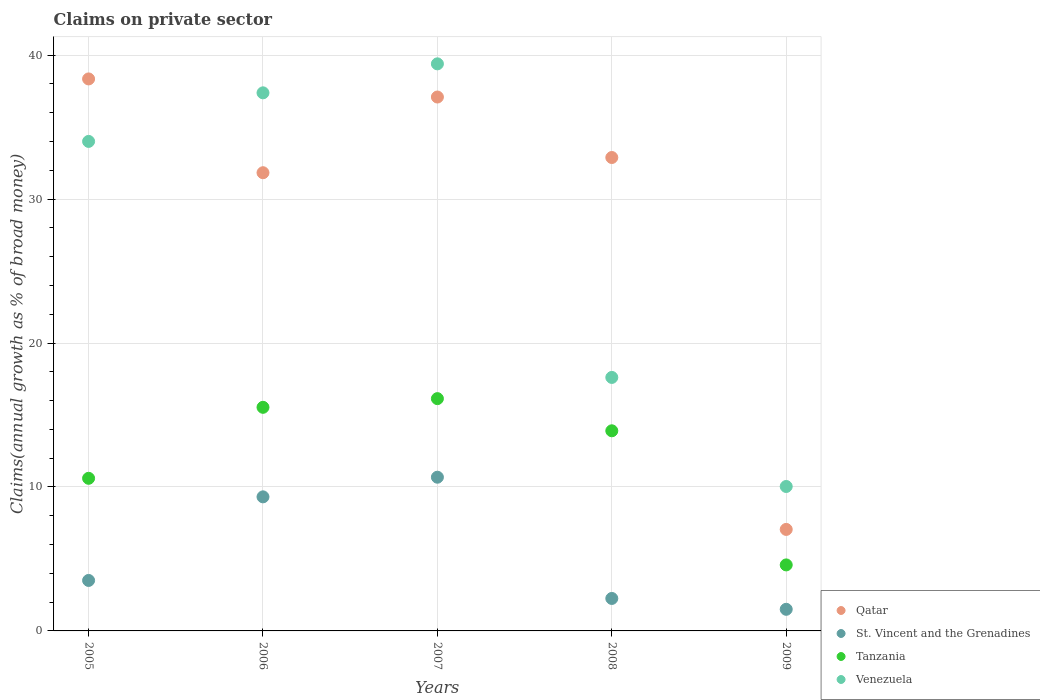What is the percentage of broad money claimed on private sector in Venezuela in 2007?
Your answer should be compact. 39.39. Across all years, what is the maximum percentage of broad money claimed on private sector in Venezuela?
Your response must be concise. 39.39. Across all years, what is the minimum percentage of broad money claimed on private sector in St. Vincent and the Grenadines?
Provide a short and direct response. 1.5. In which year was the percentage of broad money claimed on private sector in St. Vincent and the Grenadines maximum?
Give a very brief answer. 2007. What is the total percentage of broad money claimed on private sector in Venezuela in the graph?
Provide a short and direct response. 138.42. What is the difference between the percentage of broad money claimed on private sector in St. Vincent and the Grenadines in 2006 and that in 2008?
Make the answer very short. 7.06. What is the difference between the percentage of broad money claimed on private sector in Qatar in 2007 and the percentage of broad money claimed on private sector in Venezuela in 2008?
Provide a short and direct response. 19.48. What is the average percentage of broad money claimed on private sector in Tanzania per year?
Your response must be concise. 12.15. In the year 2005, what is the difference between the percentage of broad money claimed on private sector in St. Vincent and the Grenadines and percentage of broad money claimed on private sector in Venezuela?
Make the answer very short. -30.5. In how many years, is the percentage of broad money claimed on private sector in St. Vincent and the Grenadines greater than 30 %?
Provide a succinct answer. 0. What is the ratio of the percentage of broad money claimed on private sector in St. Vincent and the Grenadines in 2007 to that in 2009?
Ensure brevity in your answer.  7.11. Is the percentage of broad money claimed on private sector in Qatar in 2005 less than that in 2009?
Provide a succinct answer. No. What is the difference between the highest and the second highest percentage of broad money claimed on private sector in Venezuela?
Keep it short and to the point. 2.01. What is the difference between the highest and the lowest percentage of broad money claimed on private sector in St. Vincent and the Grenadines?
Offer a terse response. 9.18. Is the sum of the percentage of broad money claimed on private sector in Qatar in 2006 and 2007 greater than the maximum percentage of broad money claimed on private sector in Venezuela across all years?
Provide a short and direct response. Yes. Is it the case that in every year, the sum of the percentage of broad money claimed on private sector in Tanzania and percentage of broad money claimed on private sector in St. Vincent and the Grenadines  is greater than the sum of percentage of broad money claimed on private sector in Venezuela and percentage of broad money claimed on private sector in Qatar?
Provide a succinct answer. No. Is it the case that in every year, the sum of the percentage of broad money claimed on private sector in Tanzania and percentage of broad money claimed on private sector in Qatar  is greater than the percentage of broad money claimed on private sector in St. Vincent and the Grenadines?
Ensure brevity in your answer.  Yes. Does the percentage of broad money claimed on private sector in Tanzania monotonically increase over the years?
Provide a succinct answer. No. How many dotlines are there?
Make the answer very short. 4. How many years are there in the graph?
Offer a very short reply. 5. What is the difference between two consecutive major ticks on the Y-axis?
Your response must be concise. 10. Are the values on the major ticks of Y-axis written in scientific E-notation?
Ensure brevity in your answer.  No. How many legend labels are there?
Offer a terse response. 4. What is the title of the graph?
Provide a short and direct response. Claims on private sector. What is the label or title of the Y-axis?
Provide a short and direct response. Claims(annual growth as % of broad money). What is the Claims(annual growth as % of broad money) of Qatar in 2005?
Give a very brief answer. 38.35. What is the Claims(annual growth as % of broad money) in St. Vincent and the Grenadines in 2005?
Your response must be concise. 3.51. What is the Claims(annual growth as % of broad money) of Tanzania in 2005?
Your answer should be compact. 10.6. What is the Claims(annual growth as % of broad money) of Venezuela in 2005?
Provide a short and direct response. 34.01. What is the Claims(annual growth as % of broad money) of Qatar in 2006?
Your response must be concise. 31.83. What is the Claims(annual growth as % of broad money) in St. Vincent and the Grenadines in 2006?
Give a very brief answer. 9.31. What is the Claims(annual growth as % of broad money) in Tanzania in 2006?
Give a very brief answer. 15.53. What is the Claims(annual growth as % of broad money) in Venezuela in 2006?
Your answer should be very brief. 37.38. What is the Claims(annual growth as % of broad money) of Qatar in 2007?
Ensure brevity in your answer.  37.09. What is the Claims(annual growth as % of broad money) of St. Vincent and the Grenadines in 2007?
Your response must be concise. 10.68. What is the Claims(annual growth as % of broad money) of Tanzania in 2007?
Your response must be concise. 16.14. What is the Claims(annual growth as % of broad money) of Venezuela in 2007?
Provide a short and direct response. 39.39. What is the Claims(annual growth as % of broad money) of Qatar in 2008?
Ensure brevity in your answer.  32.89. What is the Claims(annual growth as % of broad money) of St. Vincent and the Grenadines in 2008?
Offer a very short reply. 2.26. What is the Claims(annual growth as % of broad money) in Tanzania in 2008?
Your answer should be very brief. 13.9. What is the Claims(annual growth as % of broad money) of Venezuela in 2008?
Keep it short and to the point. 17.61. What is the Claims(annual growth as % of broad money) of Qatar in 2009?
Make the answer very short. 7.05. What is the Claims(annual growth as % of broad money) in St. Vincent and the Grenadines in 2009?
Provide a short and direct response. 1.5. What is the Claims(annual growth as % of broad money) in Tanzania in 2009?
Provide a succinct answer. 4.59. What is the Claims(annual growth as % of broad money) in Venezuela in 2009?
Your answer should be very brief. 10.03. Across all years, what is the maximum Claims(annual growth as % of broad money) in Qatar?
Make the answer very short. 38.35. Across all years, what is the maximum Claims(annual growth as % of broad money) of St. Vincent and the Grenadines?
Make the answer very short. 10.68. Across all years, what is the maximum Claims(annual growth as % of broad money) in Tanzania?
Offer a terse response. 16.14. Across all years, what is the maximum Claims(annual growth as % of broad money) of Venezuela?
Keep it short and to the point. 39.39. Across all years, what is the minimum Claims(annual growth as % of broad money) in Qatar?
Ensure brevity in your answer.  7.05. Across all years, what is the minimum Claims(annual growth as % of broad money) in St. Vincent and the Grenadines?
Your answer should be very brief. 1.5. Across all years, what is the minimum Claims(annual growth as % of broad money) in Tanzania?
Your response must be concise. 4.59. Across all years, what is the minimum Claims(annual growth as % of broad money) of Venezuela?
Provide a succinct answer. 10.03. What is the total Claims(annual growth as % of broad money) in Qatar in the graph?
Your answer should be compact. 147.2. What is the total Claims(annual growth as % of broad money) of St. Vincent and the Grenadines in the graph?
Provide a short and direct response. 27.26. What is the total Claims(annual growth as % of broad money) in Tanzania in the graph?
Offer a terse response. 60.76. What is the total Claims(annual growth as % of broad money) in Venezuela in the graph?
Provide a short and direct response. 138.42. What is the difference between the Claims(annual growth as % of broad money) of Qatar in 2005 and that in 2006?
Provide a succinct answer. 6.52. What is the difference between the Claims(annual growth as % of broad money) of St. Vincent and the Grenadines in 2005 and that in 2006?
Provide a succinct answer. -5.81. What is the difference between the Claims(annual growth as % of broad money) in Tanzania in 2005 and that in 2006?
Offer a very short reply. -4.93. What is the difference between the Claims(annual growth as % of broad money) in Venezuela in 2005 and that in 2006?
Offer a terse response. -3.37. What is the difference between the Claims(annual growth as % of broad money) of Qatar in 2005 and that in 2007?
Offer a terse response. 1.26. What is the difference between the Claims(annual growth as % of broad money) of St. Vincent and the Grenadines in 2005 and that in 2007?
Keep it short and to the point. -7.17. What is the difference between the Claims(annual growth as % of broad money) of Tanzania in 2005 and that in 2007?
Offer a very short reply. -5.53. What is the difference between the Claims(annual growth as % of broad money) in Venezuela in 2005 and that in 2007?
Give a very brief answer. -5.39. What is the difference between the Claims(annual growth as % of broad money) in Qatar in 2005 and that in 2008?
Give a very brief answer. 5.46. What is the difference between the Claims(annual growth as % of broad money) of St. Vincent and the Grenadines in 2005 and that in 2008?
Keep it short and to the point. 1.25. What is the difference between the Claims(annual growth as % of broad money) in Tanzania in 2005 and that in 2008?
Your answer should be compact. -3.3. What is the difference between the Claims(annual growth as % of broad money) of Venezuela in 2005 and that in 2008?
Provide a short and direct response. 16.4. What is the difference between the Claims(annual growth as % of broad money) of Qatar in 2005 and that in 2009?
Make the answer very short. 31.29. What is the difference between the Claims(annual growth as % of broad money) of St. Vincent and the Grenadines in 2005 and that in 2009?
Provide a succinct answer. 2. What is the difference between the Claims(annual growth as % of broad money) of Tanzania in 2005 and that in 2009?
Offer a very short reply. 6.02. What is the difference between the Claims(annual growth as % of broad money) of Venezuela in 2005 and that in 2009?
Your answer should be compact. 23.97. What is the difference between the Claims(annual growth as % of broad money) in Qatar in 2006 and that in 2007?
Your answer should be compact. -5.26. What is the difference between the Claims(annual growth as % of broad money) in St. Vincent and the Grenadines in 2006 and that in 2007?
Ensure brevity in your answer.  -1.36. What is the difference between the Claims(annual growth as % of broad money) in Tanzania in 2006 and that in 2007?
Offer a very short reply. -0.6. What is the difference between the Claims(annual growth as % of broad money) of Venezuela in 2006 and that in 2007?
Provide a succinct answer. -2.01. What is the difference between the Claims(annual growth as % of broad money) of Qatar in 2006 and that in 2008?
Your response must be concise. -1.06. What is the difference between the Claims(annual growth as % of broad money) in St. Vincent and the Grenadines in 2006 and that in 2008?
Ensure brevity in your answer.  7.06. What is the difference between the Claims(annual growth as % of broad money) in Tanzania in 2006 and that in 2008?
Provide a short and direct response. 1.63. What is the difference between the Claims(annual growth as % of broad money) of Venezuela in 2006 and that in 2008?
Keep it short and to the point. 19.77. What is the difference between the Claims(annual growth as % of broad money) of Qatar in 2006 and that in 2009?
Provide a succinct answer. 24.78. What is the difference between the Claims(annual growth as % of broad money) in St. Vincent and the Grenadines in 2006 and that in 2009?
Provide a short and direct response. 7.81. What is the difference between the Claims(annual growth as % of broad money) in Tanzania in 2006 and that in 2009?
Provide a succinct answer. 10.95. What is the difference between the Claims(annual growth as % of broad money) in Venezuela in 2006 and that in 2009?
Offer a very short reply. 27.35. What is the difference between the Claims(annual growth as % of broad money) in Qatar in 2007 and that in 2008?
Offer a terse response. 4.2. What is the difference between the Claims(annual growth as % of broad money) in St. Vincent and the Grenadines in 2007 and that in 2008?
Keep it short and to the point. 8.42. What is the difference between the Claims(annual growth as % of broad money) in Tanzania in 2007 and that in 2008?
Your answer should be compact. 2.23. What is the difference between the Claims(annual growth as % of broad money) of Venezuela in 2007 and that in 2008?
Give a very brief answer. 21.78. What is the difference between the Claims(annual growth as % of broad money) in Qatar in 2007 and that in 2009?
Provide a short and direct response. 30.04. What is the difference between the Claims(annual growth as % of broad money) of St. Vincent and the Grenadines in 2007 and that in 2009?
Your answer should be very brief. 9.18. What is the difference between the Claims(annual growth as % of broad money) in Tanzania in 2007 and that in 2009?
Keep it short and to the point. 11.55. What is the difference between the Claims(annual growth as % of broad money) of Venezuela in 2007 and that in 2009?
Your answer should be compact. 29.36. What is the difference between the Claims(annual growth as % of broad money) of Qatar in 2008 and that in 2009?
Provide a short and direct response. 25.84. What is the difference between the Claims(annual growth as % of broad money) of St. Vincent and the Grenadines in 2008 and that in 2009?
Keep it short and to the point. 0.75. What is the difference between the Claims(annual growth as % of broad money) in Tanzania in 2008 and that in 2009?
Your response must be concise. 9.32. What is the difference between the Claims(annual growth as % of broad money) of Venezuela in 2008 and that in 2009?
Provide a short and direct response. 7.58. What is the difference between the Claims(annual growth as % of broad money) in Qatar in 2005 and the Claims(annual growth as % of broad money) in St. Vincent and the Grenadines in 2006?
Offer a very short reply. 29.03. What is the difference between the Claims(annual growth as % of broad money) in Qatar in 2005 and the Claims(annual growth as % of broad money) in Tanzania in 2006?
Offer a very short reply. 22.81. What is the difference between the Claims(annual growth as % of broad money) of Qatar in 2005 and the Claims(annual growth as % of broad money) of Venezuela in 2006?
Your response must be concise. 0.97. What is the difference between the Claims(annual growth as % of broad money) of St. Vincent and the Grenadines in 2005 and the Claims(annual growth as % of broad money) of Tanzania in 2006?
Provide a short and direct response. -12.03. What is the difference between the Claims(annual growth as % of broad money) in St. Vincent and the Grenadines in 2005 and the Claims(annual growth as % of broad money) in Venezuela in 2006?
Keep it short and to the point. -33.87. What is the difference between the Claims(annual growth as % of broad money) of Tanzania in 2005 and the Claims(annual growth as % of broad money) of Venezuela in 2006?
Keep it short and to the point. -26.78. What is the difference between the Claims(annual growth as % of broad money) of Qatar in 2005 and the Claims(annual growth as % of broad money) of St. Vincent and the Grenadines in 2007?
Keep it short and to the point. 27.67. What is the difference between the Claims(annual growth as % of broad money) in Qatar in 2005 and the Claims(annual growth as % of broad money) in Tanzania in 2007?
Your response must be concise. 22.21. What is the difference between the Claims(annual growth as % of broad money) of Qatar in 2005 and the Claims(annual growth as % of broad money) of Venezuela in 2007?
Make the answer very short. -1.05. What is the difference between the Claims(annual growth as % of broad money) in St. Vincent and the Grenadines in 2005 and the Claims(annual growth as % of broad money) in Tanzania in 2007?
Offer a terse response. -12.63. What is the difference between the Claims(annual growth as % of broad money) of St. Vincent and the Grenadines in 2005 and the Claims(annual growth as % of broad money) of Venezuela in 2007?
Give a very brief answer. -35.89. What is the difference between the Claims(annual growth as % of broad money) in Tanzania in 2005 and the Claims(annual growth as % of broad money) in Venezuela in 2007?
Make the answer very short. -28.79. What is the difference between the Claims(annual growth as % of broad money) in Qatar in 2005 and the Claims(annual growth as % of broad money) in St. Vincent and the Grenadines in 2008?
Your answer should be very brief. 36.09. What is the difference between the Claims(annual growth as % of broad money) of Qatar in 2005 and the Claims(annual growth as % of broad money) of Tanzania in 2008?
Ensure brevity in your answer.  24.44. What is the difference between the Claims(annual growth as % of broad money) in Qatar in 2005 and the Claims(annual growth as % of broad money) in Venezuela in 2008?
Provide a succinct answer. 20.74. What is the difference between the Claims(annual growth as % of broad money) in St. Vincent and the Grenadines in 2005 and the Claims(annual growth as % of broad money) in Tanzania in 2008?
Provide a short and direct response. -10.4. What is the difference between the Claims(annual growth as % of broad money) of St. Vincent and the Grenadines in 2005 and the Claims(annual growth as % of broad money) of Venezuela in 2008?
Keep it short and to the point. -14.1. What is the difference between the Claims(annual growth as % of broad money) in Tanzania in 2005 and the Claims(annual growth as % of broad money) in Venezuela in 2008?
Your answer should be compact. -7.01. What is the difference between the Claims(annual growth as % of broad money) in Qatar in 2005 and the Claims(annual growth as % of broad money) in St. Vincent and the Grenadines in 2009?
Your answer should be very brief. 36.84. What is the difference between the Claims(annual growth as % of broad money) in Qatar in 2005 and the Claims(annual growth as % of broad money) in Tanzania in 2009?
Keep it short and to the point. 33.76. What is the difference between the Claims(annual growth as % of broad money) in Qatar in 2005 and the Claims(annual growth as % of broad money) in Venezuela in 2009?
Make the answer very short. 28.31. What is the difference between the Claims(annual growth as % of broad money) in St. Vincent and the Grenadines in 2005 and the Claims(annual growth as % of broad money) in Tanzania in 2009?
Give a very brief answer. -1.08. What is the difference between the Claims(annual growth as % of broad money) in St. Vincent and the Grenadines in 2005 and the Claims(annual growth as % of broad money) in Venezuela in 2009?
Offer a terse response. -6.53. What is the difference between the Claims(annual growth as % of broad money) in Tanzania in 2005 and the Claims(annual growth as % of broad money) in Venezuela in 2009?
Provide a short and direct response. 0.57. What is the difference between the Claims(annual growth as % of broad money) in Qatar in 2006 and the Claims(annual growth as % of broad money) in St. Vincent and the Grenadines in 2007?
Your response must be concise. 21.15. What is the difference between the Claims(annual growth as % of broad money) in Qatar in 2006 and the Claims(annual growth as % of broad money) in Tanzania in 2007?
Your answer should be very brief. 15.69. What is the difference between the Claims(annual growth as % of broad money) in Qatar in 2006 and the Claims(annual growth as % of broad money) in Venezuela in 2007?
Your response must be concise. -7.56. What is the difference between the Claims(annual growth as % of broad money) of St. Vincent and the Grenadines in 2006 and the Claims(annual growth as % of broad money) of Tanzania in 2007?
Provide a short and direct response. -6.82. What is the difference between the Claims(annual growth as % of broad money) in St. Vincent and the Grenadines in 2006 and the Claims(annual growth as % of broad money) in Venezuela in 2007?
Make the answer very short. -30.08. What is the difference between the Claims(annual growth as % of broad money) of Tanzania in 2006 and the Claims(annual growth as % of broad money) of Venezuela in 2007?
Your answer should be compact. -23.86. What is the difference between the Claims(annual growth as % of broad money) in Qatar in 2006 and the Claims(annual growth as % of broad money) in St. Vincent and the Grenadines in 2008?
Your response must be concise. 29.58. What is the difference between the Claims(annual growth as % of broad money) of Qatar in 2006 and the Claims(annual growth as % of broad money) of Tanzania in 2008?
Provide a succinct answer. 17.93. What is the difference between the Claims(annual growth as % of broad money) in Qatar in 2006 and the Claims(annual growth as % of broad money) in Venezuela in 2008?
Provide a succinct answer. 14.22. What is the difference between the Claims(annual growth as % of broad money) in St. Vincent and the Grenadines in 2006 and the Claims(annual growth as % of broad money) in Tanzania in 2008?
Offer a terse response. -4.59. What is the difference between the Claims(annual growth as % of broad money) of St. Vincent and the Grenadines in 2006 and the Claims(annual growth as % of broad money) of Venezuela in 2008?
Your response must be concise. -8.3. What is the difference between the Claims(annual growth as % of broad money) of Tanzania in 2006 and the Claims(annual growth as % of broad money) of Venezuela in 2008?
Ensure brevity in your answer.  -2.08. What is the difference between the Claims(annual growth as % of broad money) in Qatar in 2006 and the Claims(annual growth as % of broad money) in St. Vincent and the Grenadines in 2009?
Keep it short and to the point. 30.33. What is the difference between the Claims(annual growth as % of broad money) in Qatar in 2006 and the Claims(annual growth as % of broad money) in Tanzania in 2009?
Give a very brief answer. 27.24. What is the difference between the Claims(annual growth as % of broad money) in Qatar in 2006 and the Claims(annual growth as % of broad money) in Venezuela in 2009?
Offer a very short reply. 21.8. What is the difference between the Claims(annual growth as % of broad money) in St. Vincent and the Grenadines in 2006 and the Claims(annual growth as % of broad money) in Tanzania in 2009?
Your answer should be compact. 4.73. What is the difference between the Claims(annual growth as % of broad money) in St. Vincent and the Grenadines in 2006 and the Claims(annual growth as % of broad money) in Venezuela in 2009?
Your answer should be very brief. -0.72. What is the difference between the Claims(annual growth as % of broad money) of Tanzania in 2006 and the Claims(annual growth as % of broad money) of Venezuela in 2009?
Your answer should be very brief. 5.5. What is the difference between the Claims(annual growth as % of broad money) in Qatar in 2007 and the Claims(annual growth as % of broad money) in St. Vincent and the Grenadines in 2008?
Make the answer very short. 34.83. What is the difference between the Claims(annual growth as % of broad money) in Qatar in 2007 and the Claims(annual growth as % of broad money) in Tanzania in 2008?
Provide a succinct answer. 23.19. What is the difference between the Claims(annual growth as % of broad money) in Qatar in 2007 and the Claims(annual growth as % of broad money) in Venezuela in 2008?
Make the answer very short. 19.48. What is the difference between the Claims(annual growth as % of broad money) in St. Vincent and the Grenadines in 2007 and the Claims(annual growth as % of broad money) in Tanzania in 2008?
Make the answer very short. -3.22. What is the difference between the Claims(annual growth as % of broad money) in St. Vincent and the Grenadines in 2007 and the Claims(annual growth as % of broad money) in Venezuela in 2008?
Offer a terse response. -6.93. What is the difference between the Claims(annual growth as % of broad money) of Tanzania in 2007 and the Claims(annual growth as % of broad money) of Venezuela in 2008?
Offer a terse response. -1.47. What is the difference between the Claims(annual growth as % of broad money) of Qatar in 2007 and the Claims(annual growth as % of broad money) of St. Vincent and the Grenadines in 2009?
Keep it short and to the point. 35.59. What is the difference between the Claims(annual growth as % of broad money) of Qatar in 2007 and the Claims(annual growth as % of broad money) of Tanzania in 2009?
Ensure brevity in your answer.  32.5. What is the difference between the Claims(annual growth as % of broad money) of Qatar in 2007 and the Claims(annual growth as % of broad money) of Venezuela in 2009?
Make the answer very short. 27.05. What is the difference between the Claims(annual growth as % of broad money) of St. Vincent and the Grenadines in 2007 and the Claims(annual growth as % of broad money) of Tanzania in 2009?
Your response must be concise. 6.09. What is the difference between the Claims(annual growth as % of broad money) in St. Vincent and the Grenadines in 2007 and the Claims(annual growth as % of broad money) in Venezuela in 2009?
Your answer should be very brief. 0.64. What is the difference between the Claims(annual growth as % of broad money) of Tanzania in 2007 and the Claims(annual growth as % of broad money) of Venezuela in 2009?
Provide a succinct answer. 6.1. What is the difference between the Claims(annual growth as % of broad money) of Qatar in 2008 and the Claims(annual growth as % of broad money) of St. Vincent and the Grenadines in 2009?
Keep it short and to the point. 31.39. What is the difference between the Claims(annual growth as % of broad money) in Qatar in 2008 and the Claims(annual growth as % of broad money) in Tanzania in 2009?
Ensure brevity in your answer.  28.3. What is the difference between the Claims(annual growth as % of broad money) in Qatar in 2008 and the Claims(annual growth as % of broad money) in Venezuela in 2009?
Make the answer very short. 22.85. What is the difference between the Claims(annual growth as % of broad money) in St. Vincent and the Grenadines in 2008 and the Claims(annual growth as % of broad money) in Tanzania in 2009?
Give a very brief answer. -2.33. What is the difference between the Claims(annual growth as % of broad money) of St. Vincent and the Grenadines in 2008 and the Claims(annual growth as % of broad money) of Venezuela in 2009?
Ensure brevity in your answer.  -7.78. What is the difference between the Claims(annual growth as % of broad money) of Tanzania in 2008 and the Claims(annual growth as % of broad money) of Venezuela in 2009?
Ensure brevity in your answer.  3.87. What is the average Claims(annual growth as % of broad money) of Qatar per year?
Make the answer very short. 29.44. What is the average Claims(annual growth as % of broad money) in St. Vincent and the Grenadines per year?
Keep it short and to the point. 5.45. What is the average Claims(annual growth as % of broad money) in Tanzania per year?
Your answer should be compact. 12.15. What is the average Claims(annual growth as % of broad money) in Venezuela per year?
Your answer should be compact. 27.68. In the year 2005, what is the difference between the Claims(annual growth as % of broad money) of Qatar and Claims(annual growth as % of broad money) of St. Vincent and the Grenadines?
Provide a short and direct response. 34.84. In the year 2005, what is the difference between the Claims(annual growth as % of broad money) in Qatar and Claims(annual growth as % of broad money) in Tanzania?
Provide a succinct answer. 27.74. In the year 2005, what is the difference between the Claims(annual growth as % of broad money) in Qatar and Claims(annual growth as % of broad money) in Venezuela?
Your answer should be very brief. 4.34. In the year 2005, what is the difference between the Claims(annual growth as % of broad money) in St. Vincent and the Grenadines and Claims(annual growth as % of broad money) in Tanzania?
Your answer should be compact. -7.1. In the year 2005, what is the difference between the Claims(annual growth as % of broad money) in St. Vincent and the Grenadines and Claims(annual growth as % of broad money) in Venezuela?
Your answer should be compact. -30.5. In the year 2005, what is the difference between the Claims(annual growth as % of broad money) of Tanzania and Claims(annual growth as % of broad money) of Venezuela?
Your answer should be compact. -23.4. In the year 2006, what is the difference between the Claims(annual growth as % of broad money) of Qatar and Claims(annual growth as % of broad money) of St. Vincent and the Grenadines?
Offer a very short reply. 22.52. In the year 2006, what is the difference between the Claims(annual growth as % of broad money) in Qatar and Claims(annual growth as % of broad money) in Tanzania?
Ensure brevity in your answer.  16.3. In the year 2006, what is the difference between the Claims(annual growth as % of broad money) of Qatar and Claims(annual growth as % of broad money) of Venezuela?
Your answer should be compact. -5.55. In the year 2006, what is the difference between the Claims(annual growth as % of broad money) in St. Vincent and the Grenadines and Claims(annual growth as % of broad money) in Tanzania?
Ensure brevity in your answer.  -6.22. In the year 2006, what is the difference between the Claims(annual growth as % of broad money) in St. Vincent and the Grenadines and Claims(annual growth as % of broad money) in Venezuela?
Keep it short and to the point. -28.07. In the year 2006, what is the difference between the Claims(annual growth as % of broad money) of Tanzania and Claims(annual growth as % of broad money) of Venezuela?
Offer a terse response. -21.85. In the year 2007, what is the difference between the Claims(annual growth as % of broad money) of Qatar and Claims(annual growth as % of broad money) of St. Vincent and the Grenadines?
Offer a terse response. 26.41. In the year 2007, what is the difference between the Claims(annual growth as % of broad money) of Qatar and Claims(annual growth as % of broad money) of Tanzania?
Offer a terse response. 20.95. In the year 2007, what is the difference between the Claims(annual growth as % of broad money) of Qatar and Claims(annual growth as % of broad money) of Venezuela?
Your answer should be compact. -2.3. In the year 2007, what is the difference between the Claims(annual growth as % of broad money) in St. Vincent and the Grenadines and Claims(annual growth as % of broad money) in Tanzania?
Offer a very short reply. -5.46. In the year 2007, what is the difference between the Claims(annual growth as % of broad money) of St. Vincent and the Grenadines and Claims(annual growth as % of broad money) of Venezuela?
Offer a very short reply. -28.72. In the year 2007, what is the difference between the Claims(annual growth as % of broad money) of Tanzania and Claims(annual growth as % of broad money) of Venezuela?
Keep it short and to the point. -23.26. In the year 2008, what is the difference between the Claims(annual growth as % of broad money) of Qatar and Claims(annual growth as % of broad money) of St. Vincent and the Grenadines?
Offer a terse response. 30.63. In the year 2008, what is the difference between the Claims(annual growth as % of broad money) of Qatar and Claims(annual growth as % of broad money) of Tanzania?
Keep it short and to the point. 18.98. In the year 2008, what is the difference between the Claims(annual growth as % of broad money) in Qatar and Claims(annual growth as % of broad money) in Venezuela?
Keep it short and to the point. 15.28. In the year 2008, what is the difference between the Claims(annual growth as % of broad money) in St. Vincent and the Grenadines and Claims(annual growth as % of broad money) in Tanzania?
Your response must be concise. -11.65. In the year 2008, what is the difference between the Claims(annual growth as % of broad money) in St. Vincent and the Grenadines and Claims(annual growth as % of broad money) in Venezuela?
Ensure brevity in your answer.  -15.35. In the year 2008, what is the difference between the Claims(annual growth as % of broad money) in Tanzania and Claims(annual growth as % of broad money) in Venezuela?
Provide a succinct answer. -3.71. In the year 2009, what is the difference between the Claims(annual growth as % of broad money) of Qatar and Claims(annual growth as % of broad money) of St. Vincent and the Grenadines?
Your response must be concise. 5.55. In the year 2009, what is the difference between the Claims(annual growth as % of broad money) of Qatar and Claims(annual growth as % of broad money) of Tanzania?
Make the answer very short. 2.47. In the year 2009, what is the difference between the Claims(annual growth as % of broad money) of Qatar and Claims(annual growth as % of broad money) of Venezuela?
Provide a succinct answer. -2.98. In the year 2009, what is the difference between the Claims(annual growth as % of broad money) of St. Vincent and the Grenadines and Claims(annual growth as % of broad money) of Tanzania?
Offer a terse response. -3.08. In the year 2009, what is the difference between the Claims(annual growth as % of broad money) in St. Vincent and the Grenadines and Claims(annual growth as % of broad money) in Venezuela?
Give a very brief answer. -8.53. In the year 2009, what is the difference between the Claims(annual growth as % of broad money) of Tanzania and Claims(annual growth as % of broad money) of Venezuela?
Provide a succinct answer. -5.45. What is the ratio of the Claims(annual growth as % of broad money) in Qatar in 2005 to that in 2006?
Your answer should be very brief. 1.2. What is the ratio of the Claims(annual growth as % of broad money) of St. Vincent and the Grenadines in 2005 to that in 2006?
Offer a terse response. 0.38. What is the ratio of the Claims(annual growth as % of broad money) in Tanzania in 2005 to that in 2006?
Give a very brief answer. 0.68. What is the ratio of the Claims(annual growth as % of broad money) in Venezuela in 2005 to that in 2006?
Offer a terse response. 0.91. What is the ratio of the Claims(annual growth as % of broad money) of Qatar in 2005 to that in 2007?
Your response must be concise. 1.03. What is the ratio of the Claims(annual growth as % of broad money) of St. Vincent and the Grenadines in 2005 to that in 2007?
Ensure brevity in your answer.  0.33. What is the ratio of the Claims(annual growth as % of broad money) of Tanzania in 2005 to that in 2007?
Offer a terse response. 0.66. What is the ratio of the Claims(annual growth as % of broad money) in Venezuela in 2005 to that in 2007?
Provide a succinct answer. 0.86. What is the ratio of the Claims(annual growth as % of broad money) in Qatar in 2005 to that in 2008?
Your answer should be very brief. 1.17. What is the ratio of the Claims(annual growth as % of broad money) in St. Vincent and the Grenadines in 2005 to that in 2008?
Give a very brief answer. 1.55. What is the ratio of the Claims(annual growth as % of broad money) in Tanzania in 2005 to that in 2008?
Your response must be concise. 0.76. What is the ratio of the Claims(annual growth as % of broad money) of Venezuela in 2005 to that in 2008?
Keep it short and to the point. 1.93. What is the ratio of the Claims(annual growth as % of broad money) of Qatar in 2005 to that in 2009?
Give a very brief answer. 5.44. What is the ratio of the Claims(annual growth as % of broad money) in St. Vincent and the Grenadines in 2005 to that in 2009?
Give a very brief answer. 2.33. What is the ratio of the Claims(annual growth as % of broad money) of Tanzania in 2005 to that in 2009?
Offer a very short reply. 2.31. What is the ratio of the Claims(annual growth as % of broad money) in Venezuela in 2005 to that in 2009?
Make the answer very short. 3.39. What is the ratio of the Claims(annual growth as % of broad money) in Qatar in 2006 to that in 2007?
Provide a succinct answer. 0.86. What is the ratio of the Claims(annual growth as % of broad money) of St. Vincent and the Grenadines in 2006 to that in 2007?
Your answer should be compact. 0.87. What is the ratio of the Claims(annual growth as % of broad money) in Tanzania in 2006 to that in 2007?
Your answer should be very brief. 0.96. What is the ratio of the Claims(annual growth as % of broad money) in Venezuela in 2006 to that in 2007?
Provide a short and direct response. 0.95. What is the ratio of the Claims(annual growth as % of broad money) of Qatar in 2006 to that in 2008?
Make the answer very short. 0.97. What is the ratio of the Claims(annual growth as % of broad money) in St. Vincent and the Grenadines in 2006 to that in 2008?
Your answer should be compact. 4.13. What is the ratio of the Claims(annual growth as % of broad money) in Tanzania in 2006 to that in 2008?
Provide a short and direct response. 1.12. What is the ratio of the Claims(annual growth as % of broad money) in Venezuela in 2006 to that in 2008?
Offer a terse response. 2.12. What is the ratio of the Claims(annual growth as % of broad money) in Qatar in 2006 to that in 2009?
Your answer should be very brief. 4.51. What is the ratio of the Claims(annual growth as % of broad money) of St. Vincent and the Grenadines in 2006 to that in 2009?
Offer a terse response. 6.2. What is the ratio of the Claims(annual growth as % of broad money) in Tanzania in 2006 to that in 2009?
Your answer should be very brief. 3.39. What is the ratio of the Claims(annual growth as % of broad money) of Venezuela in 2006 to that in 2009?
Give a very brief answer. 3.73. What is the ratio of the Claims(annual growth as % of broad money) of Qatar in 2007 to that in 2008?
Keep it short and to the point. 1.13. What is the ratio of the Claims(annual growth as % of broad money) in St. Vincent and the Grenadines in 2007 to that in 2008?
Your answer should be compact. 4.73. What is the ratio of the Claims(annual growth as % of broad money) in Tanzania in 2007 to that in 2008?
Your answer should be compact. 1.16. What is the ratio of the Claims(annual growth as % of broad money) of Venezuela in 2007 to that in 2008?
Your answer should be compact. 2.24. What is the ratio of the Claims(annual growth as % of broad money) of Qatar in 2007 to that in 2009?
Provide a short and direct response. 5.26. What is the ratio of the Claims(annual growth as % of broad money) in St. Vincent and the Grenadines in 2007 to that in 2009?
Offer a very short reply. 7.11. What is the ratio of the Claims(annual growth as % of broad money) of Tanzania in 2007 to that in 2009?
Give a very brief answer. 3.52. What is the ratio of the Claims(annual growth as % of broad money) in Venezuela in 2007 to that in 2009?
Provide a succinct answer. 3.93. What is the ratio of the Claims(annual growth as % of broad money) in Qatar in 2008 to that in 2009?
Your answer should be compact. 4.66. What is the ratio of the Claims(annual growth as % of broad money) of St. Vincent and the Grenadines in 2008 to that in 2009?
Give a very brief answer. 1.5. What is the ratio of the Claims(annual growth as % of broad money) in Tanzania in 2008 to that in 2009?
Offer a very short reply. 3.03. What is the ratio of the Claims(annual growth as % of broad money) in Venezuela in 2008 to that in 2009?
Give a very brief answer. 1.75. What is the difference between the highest and the second highest Claims(annual growth as % of broad money) in Qatar?
Your response must be concise. 1.26. What is the difference between the highest and the second highest Claims(annual growth as % of broad money) in St. Vincent and the Grenadines?
Your response must be concise. 1.36. What is the difference between the highest and the second highest Claims(annual growth as % of broad money) of Tanzania?
Provide a succinct answer. 0.6. What is the difference between the highest and the second highest Claims(annual growth as % of broad money) of Venezuela?
Make the answer very short. 2.01. What is the difference between the highest and the lowest Claims(annual growth as % of broad money) in Qatar?
Give a very brief answer. 31.29. What is the difference between the highest and the lowest Claims(annual growth as % of broad money) in St. Vincent and the Grenadines?
Offer a very short reply. 9.18. What is the difference between the highest and the lowest Claims(annual growth as % of broad money) in Tanzania?
Give a very brief answer. 11.55. What is the difference between the highest and the lowest Claims(annual growth as % of broad money) of Venezuela?
Provide a short and direct response. 29.36. 